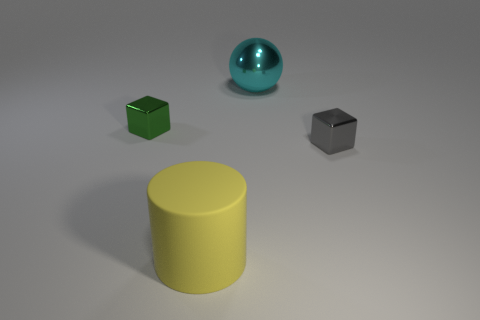Add 4 blue metal objects. How many objects exist? 8 Subtract all balls. How many objects are left? 3 Subtract all brown matte cubes. Subtract all tiny cubes. How many objects are left? 2 Add 4 small gray metal cubes. How many small gray metal cubes are left? 5 Add 4 small shiny things. How many small shiny things exist? 6 Subtract 0 cyan cylinders. How many objects are left? 4 